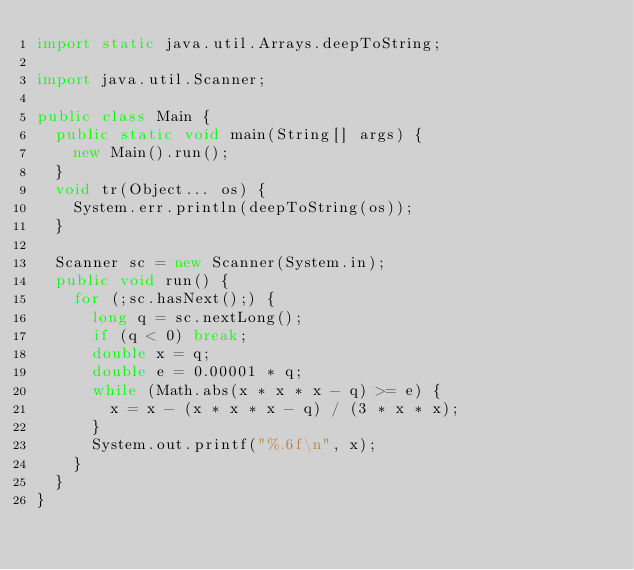<code> <loc_0><loc_0><loc_500><loc_500><_Java_>import static java.util.Arrays.deepToString;

import java.util.Scanner;

public class Main {
	public static void main(String[] args) {
		new Main().run();
	}
	void tr(Object... os) {
		System.err.println(deepToString(os));
	}

	Scanner sc = new Scanner(System.in);
	public void run() {
		for (;sc.hasNext();) {
			long q = sc.nextLong();
			if (q < 0) break;
			double x = q;
			double e = 0.00001 * q;
			while (Math.abs(x * x * x - q) >= e) {
				x = x - (x * x * x - q) / (3 * x * x);
			}
			System.out.printf("%.6f\n", x);
		}
	}
}</code> 